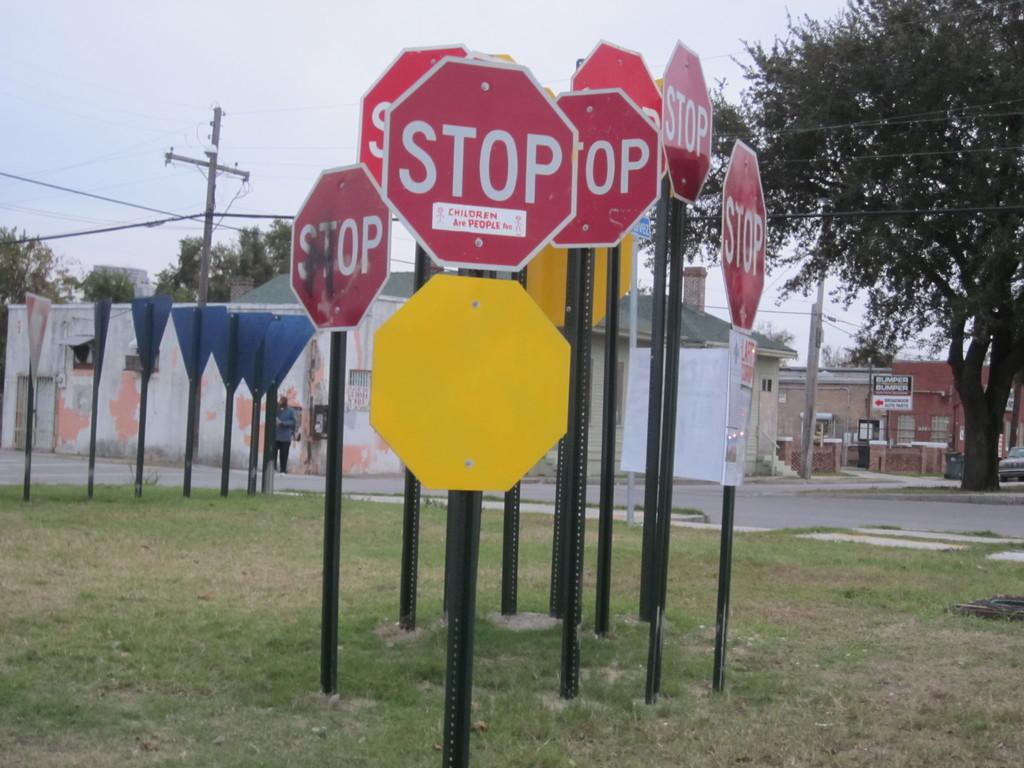What does the sign suggest?
Provide a short and direct response. Stop. What is the stop sign for?
Offer a terse response. Children. 